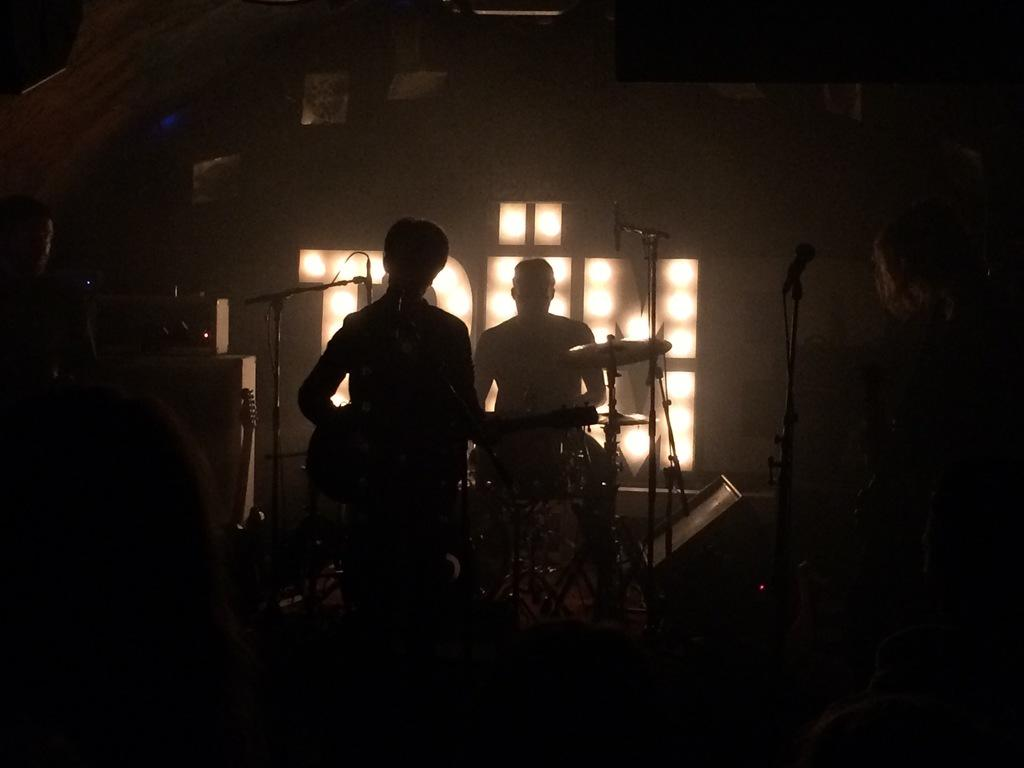How many people are in the image? There are two persons in the image. What are the persons doing in the image? The persons are playing musical instruments. What can be seen in the background of the image? There are lights visible in the background of the image. Can you tell me how many fish are swimming in the stream in the image? There is no stream or fish present in the image. What type of prison can be seen in the image? There is no prison present in the image. 